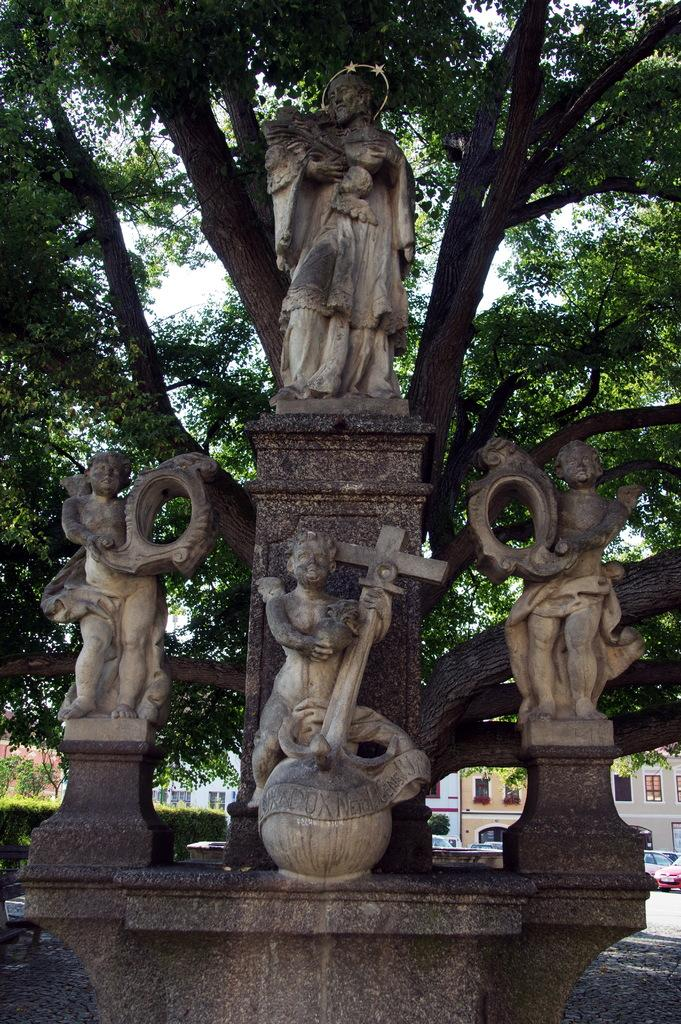What type of objects are depicted as statues in the image? There are statues of people in the image. What can be seen in the background of the image? There are many trees, vehicles on the road, buildings with windows, and the sky visible in the background of the image. What type of produce can be seen growing on the statues in the image? There are no plants or produce visible on the statues in the image. What type of destruction can be seen happening to the buildings in the image? There is no destruction visible in the image; the buildings appear intact. 